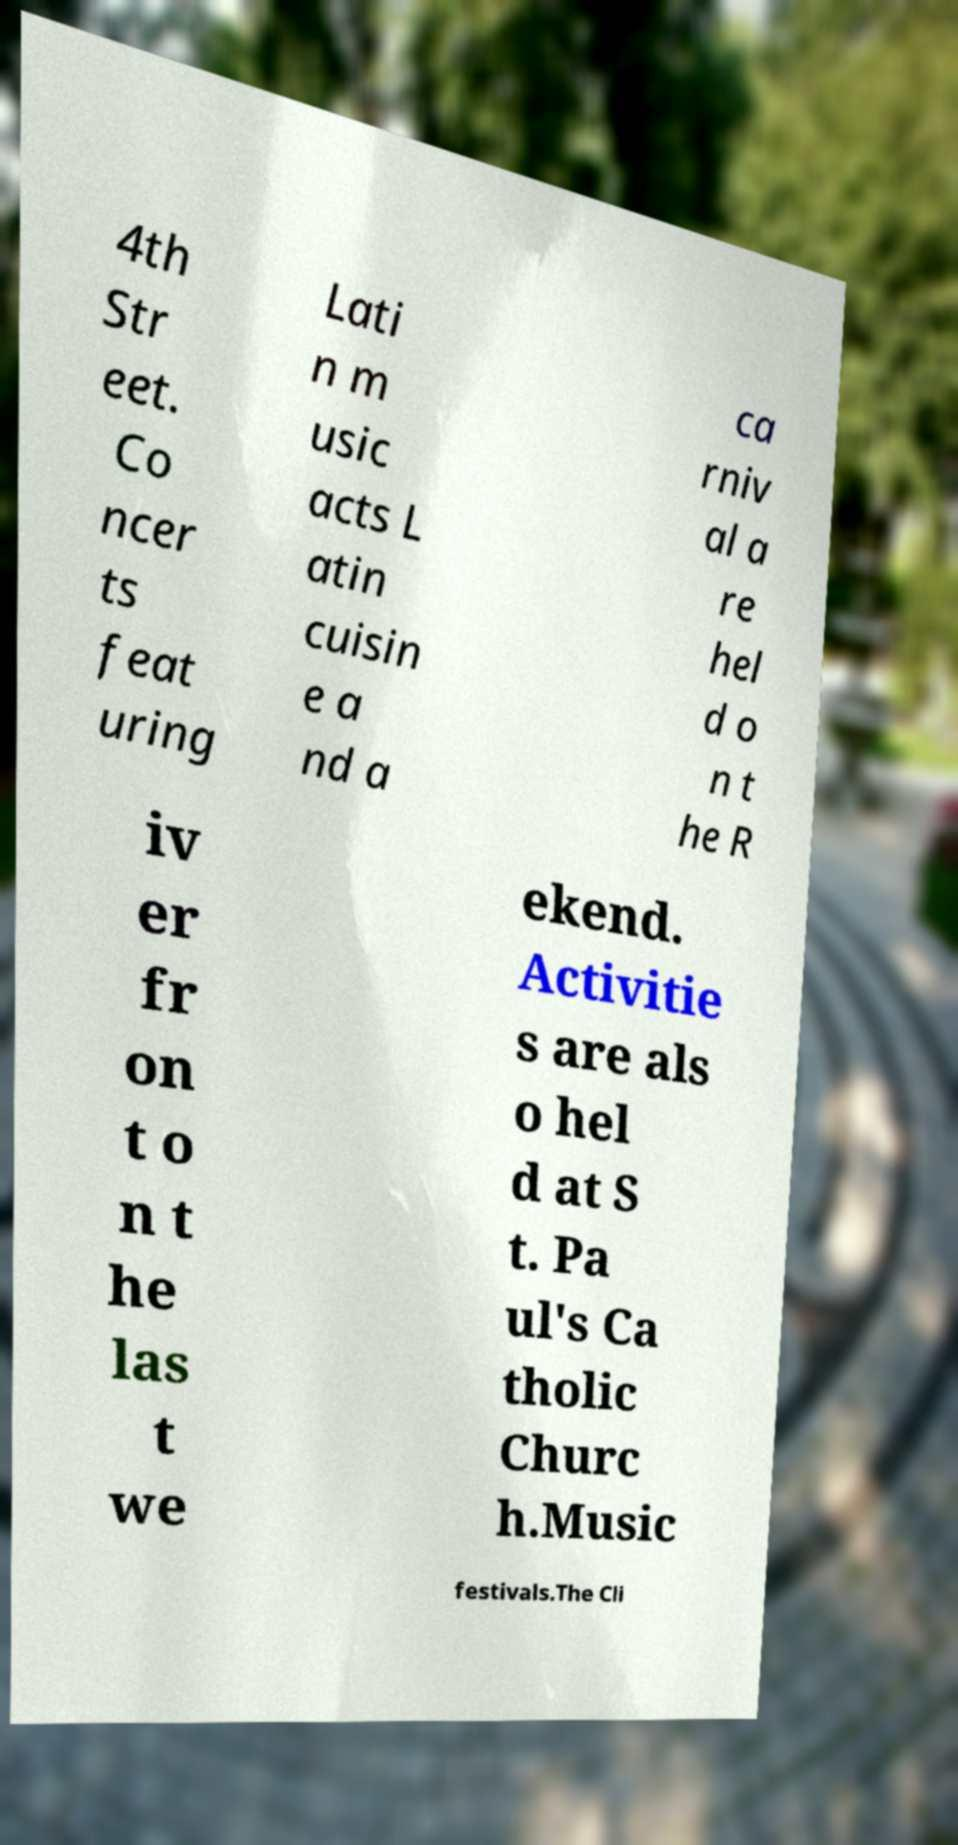I need the written content from this picture converted into text. Can you do that? 4th Str eet. Co ncer ts feat uring Lati n m usic acts L atin cuisin e a nd a ca rniv al a re hel d o n t he R iv er fr on t o n t he las t we ekend. Activitie s are als o hel d at S t. Pa ul's Ca tholic Churc h.Music festivals.The Cli 